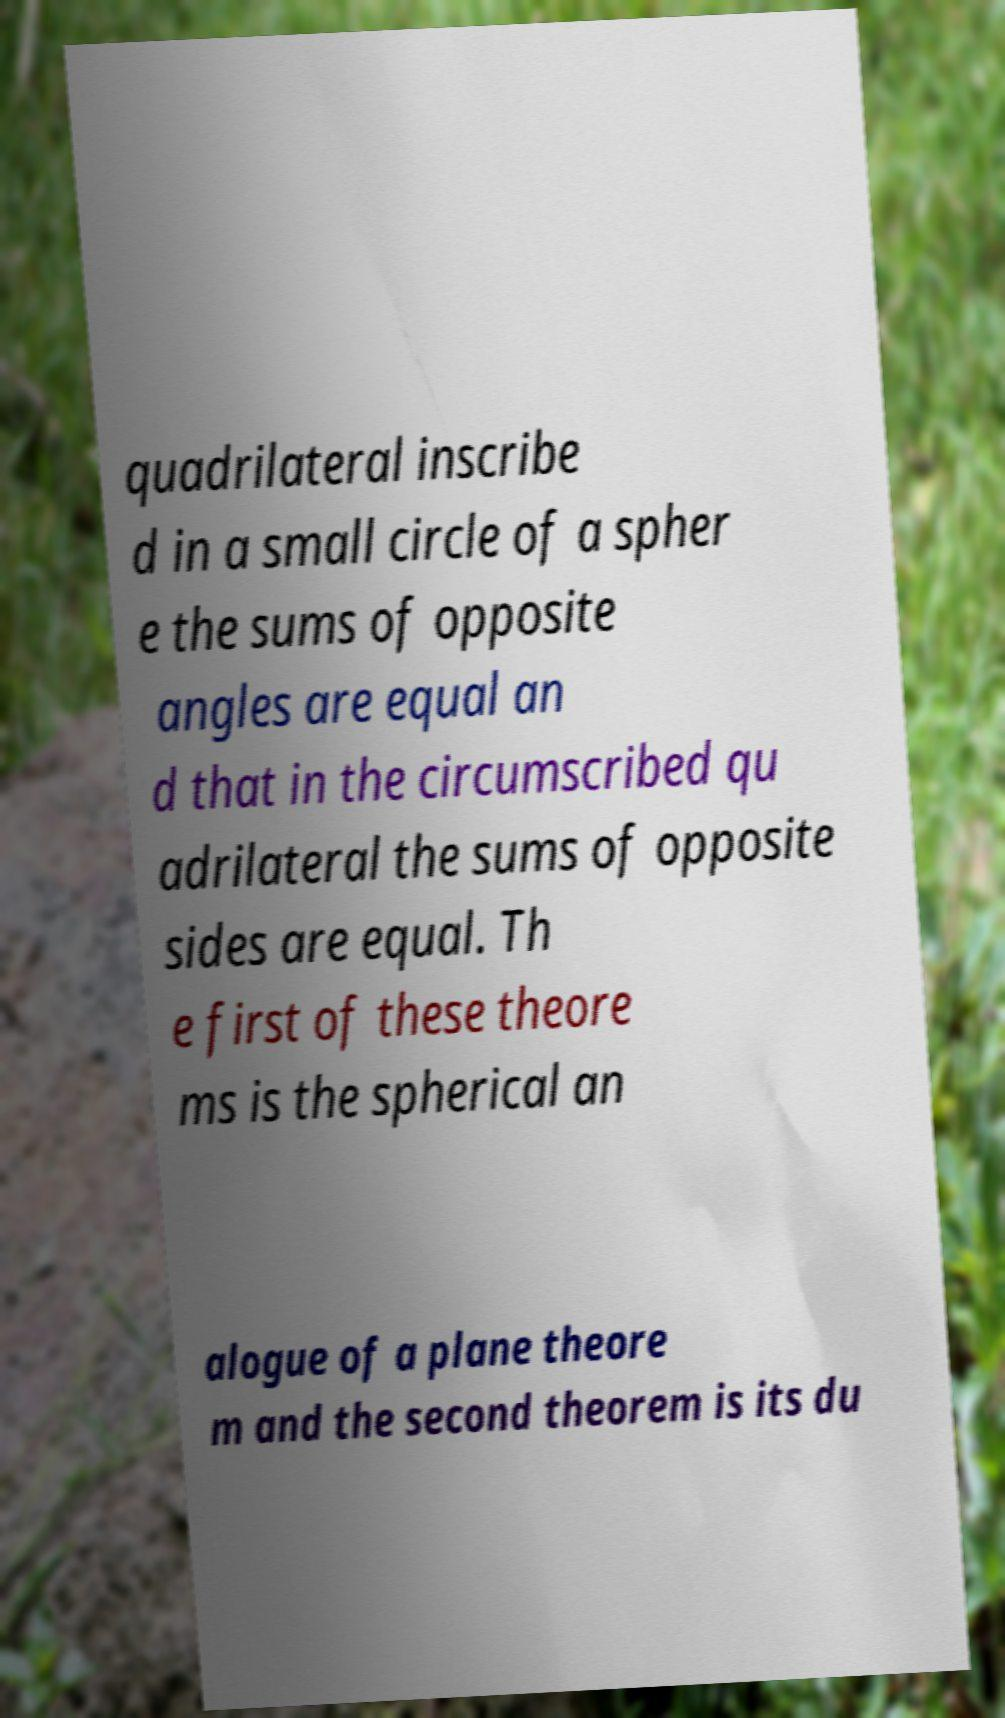Please read and relay the text visible in this image. What does it say? quadrilateral inscribe d in a small circle of a spher e the sums of opposite angles are equal an d that in the circumscribed qu adrilateral the sums of opposite sides are equal. Th e first of these theore ms is the spherical an alogue of a plane theore m and the second theorem is its du 